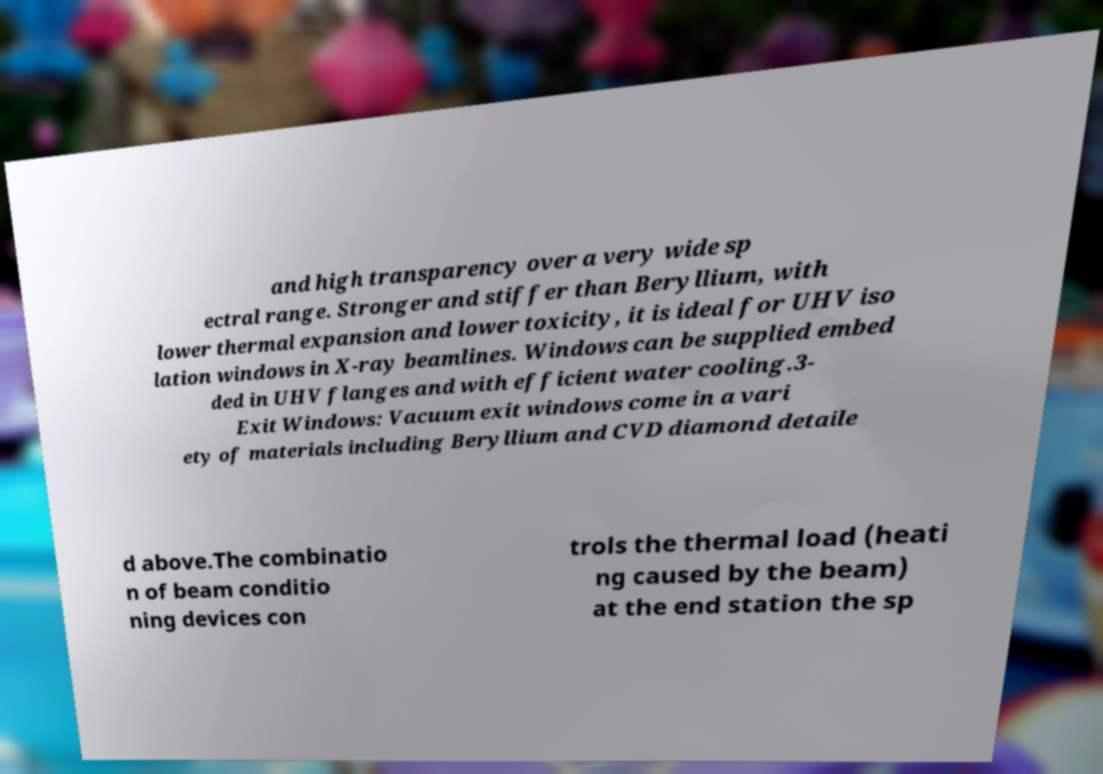Can you read and provide the text displayed in the image?This photo seems to have some interesting text. Can you extract and type it out for me? and high transparency over a very wide sp ectral range. Stronger and stiffer than Beryllium, with lower thermal expansion and lower toxicity, it is ideal for UHV iso lation windows in X-ray beamlines. Windows can be supplied embed ded in UHV flanges and with efficient water cooling.3- Exit Windows: Vacuum exit windows come in a vari ety of materials including Beryllium and CVD diamond detaile d above.The combinatio n of beam conditio ning devices con trols the thermal load (heati ng caused by the beam) at the end station the sp 